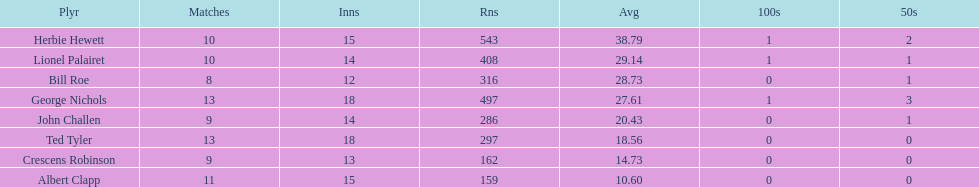How many runs did ted tyler have? 297. 